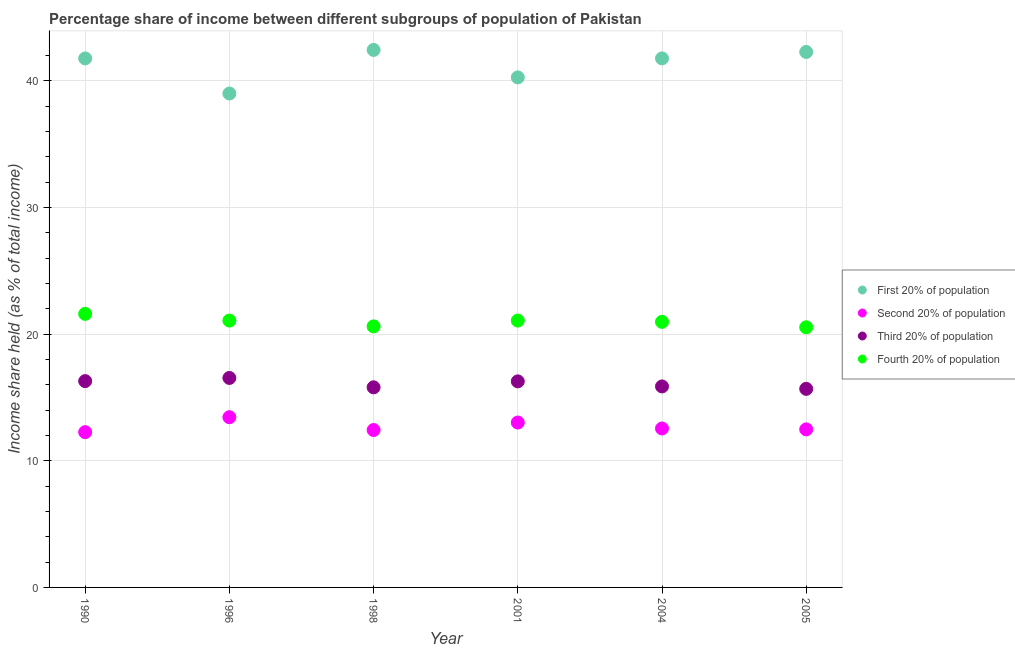How many different coloured dotlines are there?
Make the answer very short. 4. What is the share of the income held by second 20% of the population in 1990?
Your answer should be compact. 12.26. Across all years, what is the maximum share of the income held by first 20% of the population?
Your answer should be very brief. 42.44. Across all years, what is the minimum share of the income held by third 20% of the population?
Provide a succinct answer. 15.68. In which year was the share of the income held by third 20% of the population maximum?
Offer a terse response. 1996. In which year was the share of the income held by fourth 20% of the population minimum?
Keep it short and to the point. 2005. What is the total share of the income held by second 20% of the population in the graph?
Offer a terse response. 76.18. What is the difference between the share of the income held by fourth 20% of the population in 1990 and that in 2004?
Your answer should be very brief. 0.63. What is the difference between the share of the income held by fourth 20% of the population in 1990 and the share of the income held by first 20% of the population in 1998?
Offer a very short reply. -20.84. What is the average share of the income held by second 20% of the population per year?
Your response must be concise. 12.7. In the year 2005, what is the difference between the share of the income held by third 20% of the population and share of the income held by fourth 20% of the population?
Offer a terse response. -4.86. What is the ratio of the share of the income held by second 20% of the population in 1990 to that in 1996?
Your answer should be very brief. 0.91. Is the difference between the share of the income held by first 20% of the population in 1990 and 1996 greater than the difference between the share of the income held by second 20% of the population in 1990 and 1996?
Your response must be concise. Yes. What is the difference between the highest and the second highest share of the income held by first 20% of the population?
Provide a short and direct response. 0.16. What is the difference between the highest and the lowest share of the income held by third 20% of the population?
Provide a succinct answer. 0.86. Is it the case that in every year, the sum of the share of the income held by first 20% of the population and share of the income held by second 20% of the population is greater than the share of the income held by third 20% of the population?
Give a very brief answer. Yes. Does the share of the income held by second 20% of the population monotonically increase over the years?
Offer a very short reply. No. How many years are there in the graph?
Ensure brevity in your answer.  6. What is the difference between two consecutive major ticks on the Y-axis?
Offer a very short reply. 10. Are the values on the major ticks of Y-axis written in scientific E-notation?
Offer a terse response. No. Does the graph contain grids?
Offer a very short reply. Yes. How are the legend labels stacked?
Your response must be concise. Vertical. What is the title of the graph?
Keep it short and to the point. Percentage share of income between different subgroups of population of Pakistan. Does "Argument" appear as one of the legend labels in the graph?
Give a very brief answer. No. What is the label or title of the Y-axis?
Provide a succinct answer. Income share held (as % of total income). What is the Income share held (as % of total income) in First 20% of population in 1990?
Give a very brief answer. 41.77. What is the Income share held (as % of total income) of Second 20% of population in 1990?
Ensure brevity in your answer.  12.26. What is the Income share held (as % of total income) in Third 20% of population in 1990?
Your response must be concise. 16.29. What is the Income share held (as % of total income) in Fourth 20% of population in 1990?
Ensure brevity in your answer.  21.6. What is the Income share held (as % of total income) in Second 20% of population in 1996?
Make the answer very short. 13.44. What is the Income share held (as % of total income) of Third 20% of population in 1996?
Provide a short and direct response. 16.54. What is the Income share held (as % of total income) in Fourth 20% of population in 1996?
Give a very brief answer. 21.07. What is the Income share held (as % of total income) of First 20% of population in 1998?
Offer a terse response. 42.44. What is the Income share held (as % of total income) in Second 20% of population in 1998?
Keep it short and to the point. 12.43. What is the Income share held (as % of total income) in Fourth 20% of population in 1998?
Your answer should be very brief. 20.61. What is the Income share held (as % of total income) in First 20% of population in 2001?
Ensure brevity in your answer.  40.27. What is the Income share held (as % of total income) of Second 20% of population in 2001?
Your answer should be very brief. 13.02. What is the Income share held (as % of total income) in Third 20% of population in 2001?
Provide a short and direct response. 16.27. What is the Income share held (as % of total income) in Fourth 20% of population in 2001?
Your answer should be compact. 21.07. What is the Income share held (as % of total income) of First 20% of population in 2004?
Offer a very short reply. 41.77. What is the Income share held (as % of total income) in Second 20% of population in 2004?
Provide a short and direct response. 12.55. What is the Income share held (as % of total income) of Third 20% of population in 2004?
Give a very brief answer. 15.87. What is the Income share held (as % of total income) in Fourth 20% of population in 2004?
Offer a very short reply. 20.97. What is the Income share held (as % of total income) of First 20% of population in 2005?
Keep it short and to the point. 42.28. What is the Income share held (as % of total income) in Second 20% of population in 2005?
Give a very brief answer. 12.48. What is the Income share held (as % of total income) of Third 20% of population in 2005?
Your answer should be compact. 15.68. What is the Income share held (as % of total income) in Fourth 20% of population in 2005?
Make the answer very short. 20.54. Across all years, what is the maximum Income share held (as % of total income) in First 20% of population?
Provide a succinct answer. 42.44. Across all years, what is the maximum Income share held (as % of total income) in Second 20% of population?
Give a very brief answer. 13.44. Across all years, what is the maximum Income share held (as % of total income) of Third 20% of population?
Your answer should be compact. 16.54. Across all years, what is the maximum Income share held (as % of total income) of Fourth 20% of population?
Offer a very short reply. 21.6. Across all years, what is the minimum Income share held (as % of total income) of First 20% of population?
Offer a very short reply. 39. Across all years, what is the minimum Income share held (as % of total income) in Second 20% of population?
Your answer should be compact. 12.26. Across all years, what is the minimum Income share held (as % of total income) of Third 20% of population?
Your answer should be very brief. 15.68. Across all years, what is the minimum Income share held (as % of total income) in Fourth 20% of population?
Your response must be concise. 20.54. What is the total Income share held (as % of total income) in First 20% of population in the graph?
Make the answer very short. 247.53. What is the total Income share held (as % of total income) in Second 20% of population in the graph?
Your answer should be very brief. 76.18. What is the total Income share held (as % of total income) in Third 20% of population in the graph?
Ensure brevity in your answer.  96.45. What is the total Income share held (as % of total income) in Fourth 20% of population in the graph?
Provide a short and direct response. 125.86. What is the difference between the Income share held (as % of total income) of First 20% of population in 1990 and that in 1996?
Make the answer very short. 2.77. What is the difference between the Income share held (as % of total income) of Second 20% of population in 1990 and that in 1996?
Your answer should be very brief. -1.18. What is the difference between the Income share held (as % of total income) in Third 20% of population in 1990 and that in 1996?
Offer a terse response. -0.25. What is the difference between the Income share held (as % of total income) in Fourth 20% of population in 1990 and that in 1996?
Your response must be concise. 0.53. What is the difference between the Income share held (as % of total income) of First 20% of population in 1990 and that in 1998?
Keep it short and to the point. -0.67. What is the difference between the Income share held (as % of total income) of Second 20% of population in 1990 and that in 1998?
Give a very brief answer. -0.17. What is the difference between the Income share held (as % of total income) in Third 20% of population in 1990 and that in 1998?
Offer a terse response. 0.49. What is the difference between the Income share held (as % of total income) in Second 20% of population in 1990 and that in 2001?
Offer a very short reply. -0.76. What is the difference between the Income share held (as % of total income) in Fourth 20% of population in 1990 and that in 2001?
Your answer should be very brief. 0.53. What is the difference between the Income share held (as % of total income) in Second 20% of population in 1990 and that in 2004?
Offer a very short reply. -0.29. What is the difference between the Income share held (as % of total income) of Third 20% of population in 1990 and that in 2004?
Make the answer very short. 0.42. What is the difference between the Income share held (as % of total income) of Fourth 20% of population in 1990 and that in 2004?
Your answer should be compact. 0.63. What is the difference between the Income share held (as % of total income) in First 20% of population in 1990 and that in 2005?
Your answer should be very brief. -0.51. What is the difference between the Income share held (as % of total income) of Second 20% of population in 1990 and that in 2005?
Offer a very short reply. -0.22. What is the difference between the Income share held (as % of total income) of Third 20% of population in 1990 and that in 2005?
Give a very brief answer. 0.61. What is the difference between the Income share held (as % of total income) of Fourth 20% of population in 1990 and that in 2005?
Make the answer very short. 1.06. What is the difference between the Income share held (as % of total income) in First 20% of population in 1996 and that in 1998?
Give a very brief answer. -3.44. What is the difference between the Income share held (as % of total income) of Second 20% of population in 1996 and that in 1998?
Provide a succinct answer. 1.01. What is the difference between the Income share held (as % of total income) of Third 20% of population in 1996 and that in 1998?
Your answer should be compact. 0.74. What is the difference between the Income share held (as % of total income) in Fourth 20% of population in 1996 and that in 1998?
Keep it short and to the point. 0.46. What is the difference between the Income share held (as % of total income) of First 20% of population in 1996 and that in 2001?
Offer a terse response. -1.27. What is the difference between the Income share held (as % of total income) in Second 20% of population in 1996 and that in 2001?
Keep it short and to the point. 0.42. What is the difference between the Income share held (as % of total income) of Third 20% of population in 1996 and that in 2001?
Your answer should be very brief. 0.27. What is the difference between the Income share held (as % of total income) in First 20% of population in 1996 and that in 2004?
Your answer should be compact. -2.77. What is the difference between the Income share held (as % of total income) of Second 20% of population in 1996 and that in 2004?
Your response must be concise. 0.89. What is the difference between the Income share held (as % of total income) in Third 20% of population in 1996 and that in 2004?
Give a very brief answer. 0.67. What is the difference between the Income share held (as % of total income) in Fourth 20% of population in 1996 and that in 2004?
Offer a very short reply. 0.1. What is the difference between the Income share held (as % of total income) of First 20% of population in 1996 and that in 2005?
Provide a succinct answer. -3.28. What is the difference between the Income share held (as % of total income) in Third 20% of population in 1996 and that in 2005?
Provide a succinct answer. 0.86. What is the difference between the Income share held (as % of total income) in Fourth 20% of population in 1996 and that in 2005?
Offer a very short reply. 0.53. What is the difference between the Income share held (as % of total income) of First 20% of population in 1998 and that in 2001?
Ensure brevity in your answer.  2.17. What is the difference between the Income share held (as % of total income) in Second 20% of population in 1998 and that in 2001?
Provide a succinct answer. -0.59. What is the difference between the Income share held (as % of total income) of Third 20% of population in 1998 and that in 2001?
Give a very brief answer. -0.47. What is the difference between the Income share held (as % of total income) in Fourth 20% of population in 1998 and that in 2001?
Offer a terse response. -0.46. What is the difference between the Income share held (as % of total income) in First 20% of population in 1998 and that in 2004?
Make the answer very short. 0.67. What is the difference between the Income share held (as % of total income) of Second 20% of population in 1998 and that in 2004?
Make the answer very short. -0.12. What is the difference between the Income share held (as % of total income) of Third 20% of population in 1998 and that in 2004?
Offer a very short reply. -0.07. What is the difference between the Income share held (as % of total income) of Fourth 20% of population in 1998 and that in 2004?
Provide a short and direct response. -0.36. What is the difference between the Income share held (as % of total income) in First 20% of population in 1998 and that in 2005?
Give a very brief answer. 0.16. What is the difference between the Income share held (as % of total income) in Second 20% of population in 1998 and that in 2005?
Your response must be concise. -0.05. What is the difference between the Income share held (as % of total income) of Third 20% of population in 1998 and that in 2005?
Your answer should be compact. 0.12. What is the difference between the Income share held (as % of total income) in Fourth 20% of population in 1998 and that in 2005?
Give a very brief answer. 0.07. What is the difference between the Income share held (as % of total income) in First 20% of population in 2001 and that in 2004?
Keep it short and to the point. -1.5. What is the difference between the Income share held (as % of total income) in Second 20% of population in 2001 and that in 2004?
Your response must be concise. 0.47. What is the difference between the Income share held (as % of total income) in Fourth 20% of population in 2001 and that in 2004?
Give a very brief answer. 0.1. What is the difference between the Income share held (as % of total income) of First 20% of population in 2001 and that in 2005?
Give a very brief answer. -2.01. What is the difference between the Income share held (as % of total income) in Second 20% of population in 2001 and that in 2005?
Provide a short and direct response. 0.54. What is the difference between the Income share held (as % of total income) of Third 20% of population in 2001 and that in 2005?
Offer a terse response. 0.59. What is the difference between the Income share held (as % of total income) in Fourth 20% of population in 2001 and that in 2005?
Give a very brief answer. 0.53. What is the difference between the Income share held (as % of total income) in First 20% of population in 2004 and that in 2005?
Offer a terse response. -0.51. What is the difference between the Income share held (as % of total income) of Second 20% of population in 2004 and that in 2005?
Give a very brief answer. 0.07. What is the difference between the Income share held (as % of total income) in Third 20% of population in 2004 and that in 2005?
Your answer should be very brief. 0.19. What is the difference between the Income share held (as % of total income) of Fourth 20% of population in 2004 and that in 2005?
Your response must be concise. 0.43. What is the difference between the Income share held (as % of total income) of First 20% of population in 1990 and the Income share held (as % of total income) of Second 20% of population in 1996?
Give a very brief answer. 28.33. What is the difference between the Income share held (as % of total income) of First 20% of population in 1990 and the Income share held (as % of total income) of Third 20% of population in 1996?
Your response must be concise. 25.23. What is the difference between the Income share held (as % of total income) of First 20% of population in 1990 and the Income share held (as % of total income) of Fourth 20% of population in 1996?
Your answer should be compact. 20.7. What is the difference between the Income share held (as % of total income) in Second 20% of population in 1990 and the Income share held (as % of total income) in Third 20% of population in 1996?
Give a very brief answer. -4.28. What is the difference between the Income share held (as % of total income) of Second 20% of population in 1990 and the Income share held (as % of total income) of Fourth 20% of population in 1996?
Keep it short and to the point. -8.81. What is the difference between the Income share held (as % of total income) in Third 20% of population in 1990 and the Income share held (as % of total income) in Fourth 20% of population in 1996?
Provide a succinct answer. -4.78. What is the difference between the Income share held (as % of total income) of First 20% of population in 1990 and the Income share held (as % of total income) of Second 20% of population in 1998?
Keep it short and to the point. 29.34. What is the difference between the Income share held (as % of total income) in First 20% of population in 1990 and the Income share held (as % of total income) in Third 20% of population in 1998?
Provide a succinct answer. 25.97. What is the difference between the Income share held (as % of total income) of First 20% of population in 1990 and the Income share held (as % of total income) of Fourth 20% of population in 1998?
Make the answer very short. 21.16. What is the difference between the Income share held (as % of total income) in Second 20% of population in 1990 and the Income share held (as % of total income) in Third 20% of population in 1998?
Give a very brief answer. -3.54. What is the difference between the Income share held (as % of total income) in Second 20% of population in 1990 and the Income share held (as % of total income) in Fourth 20% of population in 1998?
Your answer should be very brief. -8.35. What is the difference between the Income share held (as % of total income) in Third 20% of population in 1990 and the Income share held (as % of total income) in Fourth 20% of population in 1998?
Keep it short and to the point. -4.32. What is the difference between the Income share held (as % of total income) of First 20% of population in 1990 and the Income share held (as % of total income) of Second 20% of population in 2001?
Make the answer very short. 28.75. What is the difference between the Income share held (as % of total income) of First 20% of population in 1990 and the Income share held (as % of total income) of Fourth 20% of population in 2001?
Make the answer very short. 20.7. What is the difference between the Income share held (as % of total income) in Second 20% of population in 1990 and the Income share held (as % of total income) in Third 20% of population in 2001?
Make the answer very short. -4.01. What is the difference between the Income share held (as % of total income) in Second 20% of population in 1990 and the Income share held (as % of total income) in Fourth 20% of population in 2001?
Ensure brevity in your answer.  -8.81. What is the difference between the Income share held (as % of total income) of Third 20% of population in 1990 and the Income share held (as % of total income) of Fourth 20% of population in 2001?
Make the answer very short. -4.78. What is the difference between the Income share held (as % of total income) in First 20% of population in 1990 and the Income share held (as % of total income) in Second 20% of population in 2004?
Provide a short and direct response. 29.22. What is the difference between the Income share held (as % of total income) of First 20% of population in 1990 and the Income share held (as % of total income) of Third 20% of population in 2004?
Your response must be concise. 25.9. What is the difference between the Income share held (as % of total income) in First 20% of population in 1990 and the Income share held (as % of total income) in Fourth 20% of population in 2004?
Provide a succinct answer. 20.8. What is the difference between the Income share held (as % of total income) in Second 20% of population in 1990 and the Income share held (as % of total income) in Third 20% of population in 2004?
Offer a terse response. -3.61. What is the difference between the Income share held (as % of total income) of Second 20% of population in 1990 and the Income share held (as % of total income) of Fourth 20% of population in 2004?
Make the answer very short. -8.71. What is the difference between the Income share held (as % of total income) in Third 20% of population in 1990 and the Income share held (as % of total income) in Fourth 20% of population in 2004?
Keep it short and to the point. -4.68. What is the difference between the Income share held (as % of total income) in First 20% of population in 1990 and the Income share held (as % of total income) in Second 20% of population in 2005?
Provide a succinct answer. 29.29. What is the difference between the Income share held (as % of total income) in First 20% of population in 1990 and the Income share held (as % of total income) in Third 20% of population in 2005?
Offer a terse response. 26.09. What is the difference between the Income share held (as % of total income) of First 20% of population in 1990 and the Income share held (as % of total income) of Fourth 20% of population in 2005?
Provide a succinct answer. 21.23. What is the difference between the Income share held (as % of total income) in Second 20% of population in 1990 and the Income share held (as % of total income) in Third 20% of population in 2005?
Keep it short and to the point. -3.42. What is the difference between the Income share held (as % of total income) in Second 20% of population in 1990 and the Income share held (as % of total income) in Fourth 20% of population in 2005?
Ensure brevity in your answer.  -8.28. What is the difference between the Income share held (as % of total income) in Third 20% of population in 1990 and the Income share held (as % of total income) in Fourth 20% of population in 2005?
Make the answer very short. -4.25. What is the difference between the Income share held (as % of total income) of First 20% of population in 1996 and the Income share held (as % of total income) of Second 20% of population in 1998?
Give a very brief answer. 26.57. What is the difference between the Income share held (as % of total income) in First 20% of population in 1996 and the Income share held (as % of total income) in Third 20% of population in 1998?
Ensure brevity in your answer.  23.2. What is the difference between the Income share held (as % of total income) of First 20% of population in 1996 and the Income share held (as % of total income) of Fourth 20% of population in 1998?
Make the answer very short. 18.39. What is the difference between the Income share held (as % of total income) in Second 20% of population in 1996 and the Income share held (as % of total income) in Third 20% of population in 1998?
Provide a short and direct response. -2.36. What is the difference between the Income share held (as % of total income) in Second 20% of population in 1996 and the Income share held (as % of total income) in Fourth 20% of population in 1998?
Offer a very short reply. -7.17. What is the difference between the Income share held (as % of total income) of Third 20% of population in 1996 and the Income share held (as % of total income) of Fourth 20% of population in 1998?
Your answer should be very brief. -4.07. What is the difference between the Income share held (as % of total income) in First 20% of population in 1996 and the Income share held (as % of total income) in Second 20% of population in 2001?
Make the answer very short. 25.98. What is the difference between the Income share held (as % of total income) in First 20% of population in 1996 and the Income share held (as % of total income) in Third 20% of population in 2001?
Give a very brief answer. 22.73. What is the difference between the Income share held (as % of total income) in First 20% of population in 1996 and the Income share held (as % of total income) in Fourth 20% of population in 2001?
Ensure brevity in your answer.  17.93. What is the difference between the Income share held (as % of total income) in Second 20% of population in 1996 and the Income share held (as % of total income) in Third 20% of population in 2001?
Offer a very short reply. -2.83. What is the difference between the Income share held (as % of total income) of Second 20% of population in 1996 and the Income share held (as % of total income) of Fourth 20% of population in 2001?
Your answer should be very brief. -7.63. What is the difference between the Income share held (as % of total income) of Third 20% of population in 1996 and the Income share held (as % of total income) of Fourth 20% of population in 2001?
Offer a terse response. -4.53. What is the difference between the Income share held (as % of total income) in First 20% of population in 1996 and the Income share held (as % of total income) in Second 20% of population in 2004?
Ensure brevity in your answer.  26.45. What is the difference between the Income share held (as % of total income) in First 20% of population in 1996 and the Income share held (as % of total income) in Third 20% of population in 2004?
Provide a succinct answer. 23.13. What is the difference between the Income share held (as % of total income) of First 20% of population in 1996 and the Income share held (as % of total income) of Fourth 20% of population in 2004?
Provide a succinct answer. 18.03. What is the difference between the Income share held (as % of total income) of Second 20% of population in 1996 and the Income share held (as % of total income) of Third 20% of population in 2004?
Offer a very short reply. -2.43. What is the difference between the Income share held (as % of total income) in Second 20% of population in 1996 and the Income share held (as % of total income) in Fourth 20% of population in 2004?
Offer a very short reply. -7.53. What is the difference between the Income share held (as % of total income) in Third 20% of population in 1996 and the Income share held (as % of total income) in Fourth 20% of population in 2004?
Provide a short and direct response. -4.43. What is the difference between the Income share held (as % of total income) in First 20% of population in 1996 and the Income share held (as % of total income) in Second 20% of population in 2005?
Offer a very short reply. 26.52. What is the difference between the Income share held (as % of total income) in First 20% of population in 1996 and the Income share held (as % of total income) in Third 20% of population in 2005?
Offer a very short reply. 23.32. What is the difference between the Income share held (as % of total income) of First 20% of population in 1996 and the Income share held (as % of total income) of Fourth 20% of population in 2005?
Make the answer very short. 18.46. What is the difference between the Income share held (as % of total income) in Second 20% of population in 1996 and the Income share held (as % of total income) in Third 20% of population in 2005?
Your answer should be compact. -2.24. What is the difference between the Income share held (as % of total income) of Third 20% of population in 1996 and the Income share held (as % of total income) of Fourth 20% of population in 2005?
Your response must be concise. -4. What is the difference between the Income share held (as % of total income) of First 20% of population in 1998 and the Income share held (as % of total income) of Second 20% of population in 2001?
Offer a terse response. 29.42. What is the difference between the Income share held (as % of total income) of First 20% of population in 1998 and the Income share held (as % of total income) of Third 20% of population in 2001?
Keep it short and to the point. 26.17. What is the difference between the Income share held (as % of total income) of First 20% of population in 1998 and the Income share held (as % of total income) of Fourth 20% of population in 2001?
Offer a terse response. 21.37. What is the difference between the Income share held (as % of total income) of Second 20% of population in 1998 and the Income share held (as % of total income) of Third 20% of population in 2001?
Your answer should be compact. -3.84. What is the difference between the Income share held (as % of total income) in Second 20% of population in 1998 and the Income share held (as % of total income) in Fourth 20% of population in 2001?
Keep it short and to the point. -8.64. What is the difference between the Income share held (as % of total income) of Third 20% of population in 1998 and the Income share held (as % of total income) of Fourth 20% of population in 2001?
Your response must be concise. -5.27. What is the difference between the Income share held (as % of total income) in First 20% of population in 1998 and the Income share held (as % of total income) in Second 20% of population in 2004?
Provide a short and direct response. 29.89. What is the difference between the Income share held (as % of total income) in First 20% of population in 1998 and the Income share held (as % of total income) in Third 20% of population in 2004?
Give a very brief answer. 26.57. What is the difference between the Income share held (as % of total income) of First 20% of population in 1998 and the Income share held (as % of total income) of Fourth 20% of population in 2004?
Keep it short and to the point. 21.47. What is the difference between the Income share held (as % of total income) of Second 20% of population in 1998 and the Income share held (as % of total income) of Third 20% of population in 2004?
Provide a short and direct response. -3.44. What is the difference between the Income share held (as % of total income) of Second 20% of population in 1998 and the Income share held (as % of total income) of Fourth 20% of population in 2004?
Your answer should be very brief. -8.54. What is the difference between the Income share held (as % of total income) in Third 20% of population in 1998 and the Income share held (as % of total income) in Fourth 20% of population in 2004?
Your response must be concise. -5.17. What is the difference between the Income share held (as % of total income) in First 20% of population in 1998 and the Income share held (as % of total income) in Second 20% of population in 2005?
Give a very brief answer. 29.96. What is the difference between the Income share held (as % of total income) in First 20% of population in 1998 and the Income share held (as % of total income) in Third 20% of population in 2005?
Keep it short and to the point. 26.76. What is the difference between the Income share held (as % of total income) in First 20% of population in 1998 and the Income share held (as % of total income) in Fourth 20% of population in 2005?
Provide a succinct answer. 21.9. What is the difference between the Income share held (as % of total income) in Second 20% of population in 1998 and the Income share held (as % of total income) in Third 20% of population in 2005?
Your answer should be very brief. -3.25. What is the difference between the Income share held (as % of total income) in Second 20% of population in 1998 and the Income share held (as % of total income) in Fourth 20% of population in 2005?
Your answer should be compact. -8.11. What is the difference between the Income share held (as % of total income) of Third 20% of population in 1998 and the Income share held (as % of total income) of Fourth 20% of population in 2005?
Your answer should be compact. -4.74. What is the difference between the Income share held (as % of total income) of First 20% of population in 2001 and the Income share held (as % of total income) of Second 20% of population in 2004?
Your response must be concise. 27.72. What is the difference between the Income share held (as % of total income) of First 20% of population in 2001 and the Income share held (as % of total income) of Third 20% of population in 2004?
Your response must be concise. 24.4. What is the difference between the Income share held (as % of total income) in First 20% of population in 2001 and the Income share held (as % of total income) in Fourth 20% of population in 2004?
Your answer should be compact. 19.3. What is the difference between the Income share held (as % of total income) of Second 20% of population in 2001 and the Income share held (as % of total income) of Third 20% of population in 2004?
Your answer should be very brief. -2.85. What is the difference between the Income share held (as % of total income) in Second 20% of population in 2001 and the Income share held (as % of total income) in Fourth 20% of population in 2004?
Your answer should be compact. -7.95. What is the difference between the Income share held (as % of total income) of Third 20% of population in 2001 and the Income share held (as % of total income) of Fourth 20% of population in 2004?
Provide a succinct answer. -4.7. What is the difference between the Income share held (as % of total income) in First 20% of population in 2001 and the Income share held (as % of total income) in Second 20% of population in 2005?
Make the answer very short. 27.79. What is the difference between the Income share held (as % of total income) of First 20% of population in 2001 and the Income share held (as % of total income) of Third 20% of population in 2005?
Offer a very short reply. 24.59. What is the difference between the Income share held (as % of total income) in First 20% of population in 2001 and the Income share held (as % of total income) in Fourth 20% of population in 2005?
Your answer should be compact. 19.73. What is the difference between the Income share held (as % of total income) of Second 20% of population in 2001 and the Income share held (as % of total income) of Third 20% of population in 2005?
Your answer should be compact. -2.66. What is the difference between the Income share held (as % of total income) of Second 20% of population in 2001 and the Income share held (as % of total income) of Fourth 20% of population in 2005?
Offer a terse response. -7.52. What is the difference between the Income share held (as % of total income) in Third 20% of population in 2001 and the Income share held (as % of total income) in Fourth 20% of population in 2005?
Your response must be concise. -4.27. What is the difference between the Income share held (as % of total income) in First 20% of population in 2004 and the Income share held (as % of total income) in Second 20% of population in 2005?
Provide a short and direct response. 29.29. What is the difference between the Income share held (as % of total income) in First 20% of population in 2004 and the Income share held (as % of total income) in Third 20% of population in 2005?
Make the answer very short. 26.09. What is the difference between the Income share held (as % of total income) of First 20% of population in 2004 and the Income share held (as % of total income) of Fourth 20% of population in 2005?
Ensure brevity in your answer.  21.23. What is the difference between the Income share held (as % of total income) in Second 20% of population in 2004 and the Income share held (as % of total income) in Third 20% of population in 2005?
Provide a succinct answer. -3.13. What is the difference between the Income share held (as % of total income) in Second 20% of population in 2004 and the Income share held (as % of total income) in Fourth 20% of population in 2005?
Your response must be concise. -7.99. What is the difference between the Income share held (as % of total income) of Third 20% of population in 2004 and the Income share held (as % of total income) of Fourth 20% of population in 2005?
Your response must be concise. -4.67. What is the average Income share held (as % of total income) of First 20% of population per year?
Provide a succinct answer. 41.26. What is the average Income share held (as % of total income) of Second 20% of population per year?
Your answer should be compact. 12.7. What is the average Income share held (as % of total income) in Third 20% of population per year?
Your response must be concise. 16.07. What is the average Income share held (as % of total income) of Fourth 20% of population per year?
Keep it short and to the point. 20.98. In the year 1990, what is the difference between the Income share held (as % of total income) in First 20% of population and Income share held (as % of total income) in Second 20% of population?
Your answer should be compact. 29.51. In the year 1990, what is the difference between the Income share held (as % of total income) of First 20% of population and Income share held (as % of total income) of Third 20% of population?
Your answer should be compact. 25.48. In the year 1990, what is the difference between the Income share held (as % of total income) in First 20% of population and Income share held (as % of total income) in Fourth 20% of population?
Offer a terse response. 20.17. In the year 1990, what is the difference between the Income share held (as % of total income) of Second 20% of population and Income share held (as % of total income) of Third 20% of population?
Keep it short and to the point. -4.03. In the year 1990, what is the difference between the Income share held (as % of total income) of Second 20% of population and Income share held (as % of total income) of Fourth 20% of population?
Provide a short and direct response. -9.34. In the year 1990, what is the difference between the Income share held (as % of total income) in Third 20% of population and Income share held (as % of total income) in Fourth 20% of population?
Make the answer very short. -5.31. In the year 1996, what is the difference between the Income share held (as % of total income) of First 20% of population and Income share held (as % of total income) of Second 20% of population?
Your response must be concise. 25.56. In the year 1996, what is the difference between the Income share held (as % of total income) of First 20% of population and Income share held (as % of total income) of Third 20% of population?
Offer a terse response. 22.46. In the year 1996, what is the difference between the Income share held (as % of total income) in First 20% of population and Income share held (as % of total income) in Fourth 20% of population?
Make the answer very short. 17.93. In the year 1996, what is the difference between the Income share held (as % of total income) of Second 20% of population and Income share held (as % of total income) of Third 20% of population?
Your response must be concise. -3.1. In the year 1996, what is the difference between the Income share held (as % of total income) of Second 20% of population and Income share held (as % of total income) of Fourth 20% of population?
Offer a very short reply. -7.63. In the year 1996, what is the difference between the Income share held (as % of total income) of Third 20% of population and Income share held (as % of total income) of Fourth 20% of population?
Keep it short and to the point. -4.53. In the year 1998, what is the difference between the Income share held (as % of total income) in First 20% of population and Income share held (as % of total income) in Second 20% of population?
Offer a terse response. 30.01. In the year 1998, what is the difference between the Income share held (as % of total income) in First 20% of population and Income share held (as % of total income) in Third 20% of population?
Provide a succinct answer. 26.64. In the year 1998, what is the difference between the Income share held (as % of total income) in First 20% of population and Income share held (as % of total income) in Fourth 20% of population?
Your answer should be compact. 21.83. In the year 1998, what is the difference between the Income share held (as % of total income) in Second 20% of population and Income share held (as % of total income) in Third 20% of population?
Keep it short and to the point. -3.37. In the year 1998, what is the difference between the Income share held (as % of total income) of Second 20% of population and Income share held (as % of total income) of Fourth 20% of population?
Offer a very short reply. -8.18. In the year 1998, what is the difference between the Income share held (as % of total income) of Third 20% of population and Income share held (as % of total income) of Fourth 20% of population?
Your answer should be compact. -4.81. In the year 2001, what is the difference between the Income share held (as % of total income) of First 20% of population and Income share held (as % of total income) of Second 20% of population?
Your response must be concise. 27.25. In the year 2001, what is the difference between the Income share held (as % of total income) in First 20% of population and Income share held (as % of total income) in Third 20% of population?
Offer a very short reply. 24. In the year 2001, what is the difference between the Income share held (as % of total income) in First 20% of population and Income share held (as % of total income) in Fourth 20% of population?
Provide a short and direct response. 19.2. In the year 2001, what is the difference between the Income share held (as % of total income) of Second 20% of population and Income share held (as % of total income) of Third 20% of population?
Your response must be concise. -3.25. In the year 2001, what is the difference between the Income share held (as % of total income) in Second 20% of population and Income share held (as % of total income) in Fourth 20% of population?
Provide a succinct answer. -8.05. In the year 2001, what is the difference between the Income share held (as % of total income) of Third 20% of population and Income share held (as % of total income) of Fourth 20% of population?
Ensure brevity in your answer.  -4.8. In the year 2004, what is the difference between the Income share held (as % of total income) in First 20% of population and Income share held (as % of total income) in Second 20% of population?
Offer a terse response. 29.22. In the year 2004, what is the difference between the Income share held (as % of total income) in First 20% of population and Income share held (as % of total income) in Third 20% of population?
Offer a terse response. 25.9. In the year 2004, what is the difference between the Income share held (as % of total income) of First 20% of population and Income share held (as % of total income) of Fourth 20% of population?
Provide a short and direct response. 20.8. In the year 2004, what is the difference between the Income share held (as % of total income) of Second 20% of population and Income share held (as % of total income) of Third 20% of population?
Provide a succinct answer. -3.32. In the year 2004, what is the difference between the Income share held (as % of total income) in Second 20% of population and Income share held (as % of total income) in Fourth 20% of population?
Provide a short and direct response. -8.42. In the year 2005, what is the difference between the Income share held (as % of total income) of First 20% of population and Income share held (as % of total income) of Second 20% of population?
Make the answer very short. 29.8. In the year 2005, what is the difference between the Income share held (as % of total income) in First 20% of population and Income share held (as % of total income) in Third 20% of population?
Your answer should be very brief. 26.6. In the year 2005, what is the difference between the Income share held (as % of total income) of First 20% of population and Income share held (as % of total income) of Fourth 20% of population?
Give a very brief answer. 21.74. In the year 2005, what is the difference between the Income share held (as % of total income) of Second 20% of population and Income share held (as % of total income) of Fourth 20% of population?
Keep it short and to the point. -8.06. In the year 2005, what is the difference between the Income share held (as % of total income) in Third 20% of population and Income share held (as % of total income) in Fourth 20% of population?
Give a very brief answer. -4.86. What is the ratio of the Income share held (as % of total income) of First 20% of population in 1990 to that in 1996?
Your response must be concise. 1.07. What is the ratio of the Income share held (as % of total income) in Second 20% of population in 1990 to that in 1996?
Make the answer very short. 0.91. What is the ratio of the Income share held (as % of total income) in Third 20% of population in 1990 to that in 1996?
Offer a very short reply. 0.98. What is the ratio of the Income share held (as % of total income) in Fourth 20% of population in 1990 to that in 1996?
Offer a terse response. 1.03. What is the ratio of the Income share held (as % of total income) of First 20% of population in 1990 to that in 1998?
Your response must be concise. 0.98. What is the ratio of the Income share held (as % of total income) in Second 20% of population in 1990 to that in 1998?
Your answer should be compact. 0.99. What is the ratio of the Income share held (as % of total income) of Third 20% of population in 1990 to that in 1998?
Your answer should be very brief. 1.03. What is the ratio of the Income share held (as % of total income) of Fourth 20% of population in 1990 to that in 1998?
Make the answer very short. 1.05. What is the ratio of the Income share held (as % of total income) of First 20% of population in 1990 to that in 2001?
Make the answer very short. 1.04. What is the ratio of the Income share held (as % of total income) of Second 20% of population in 1990 to that in 2001?
Ensure brevity in your answer.  0.94. What is the ratio of the Income share held (as % of total income) of Fourth 20% of population in 1990 to that in 2001?
Give a very brief answer. 1.03. What is the ratio of the Income share held (as % of total income) in First 20% of population in 1990 to that in 2004?
Your answer should be very brief. 1. What is the ratio of the Income share held (as % of total income) in Second 20% of population in 1990 to that in 2004?
Offer a terse response. 0.98. What is the ratio of the Income share held (as % of total income) of Third 20% of population in 1990 to that in 2004?
Keep it short and to the point. 1.03. What is the ratio of the Income share held (as % of total income) in First 20% of population in 1990 to that in 2005?
Provide a short and direct response. 0.99. What is the ratio of the Income share held (as % of total income) in Second 20% of population in 1990 to that in 2005?
Offer a very short reply. 0.98. What is the ratio of the Income share held (as % of total income) in Third 20% of population in 1990 to that in 2005?
Ensure brevity in your answer.  1.04. What is the ratio of the Income share held (as % of total income) in Fourth 20% of population in 1990 to that in 2005?
Keep it short and to the point. 1.05. What is the ratio of the Income share held (as % of total income) in First 20% of population in 1996 to that in 1998?
Provide a succinct answer. 0.92. What is the ratio of the Income share held (as % of total income) of Second 20% of population in 1996 to that in 1998?
Offer a terse response. 1.08. What is the ratio of the Income share held (as % of total income) in Third 20% of population in 1996 to that in 1998?
Give a very brief answer. 1.05. What is the ratio of the Income share held (as % of total income) of Fourth 20% of population in 1996 to that in 1998?
Ensure brevity in your answer.  1.02. What is the ratio of the Income share held (as % of total income) in First 20% of population in 1996 to that in 2001?
Offer a terse response. 0.97. What is the ratio of the Income share held (as % of total income) of Second 20% of population in 1996 to that in 2001?
Your answer should be very brief. 1.03. What is the ratio of the Income share held (as % of total income) of Third 20% of population in 1996 to that in 2001?
Ensure brevity in your answer.  1.02. What is the ratio of the Income share held (as % of total income) in First 20% of population in 1996 to that in 2004?
Provide a short and direct response. 0.93. What is the ratio of the Income share held (as % of total income) of Second 20% of population in 1996 to that in 2004?
Ensure brevity in your answer.  1.07. What is the ratio of the Income share held (as % of total income) of Third 20% of population in 1996 to that in 2004?
Offer a very short reply. 1.04. What is the ratio of the Income share held (as % of total income) in First 20% of population in 1996 to that in 2005?
Your response must be concise. 0.92. What is the ratio of the Income share held (as % of total income) in Third 20% of population in 1996 to that in 2005?
Make the answer very short. 1.05. What is the ratio of the Income share held (as % of total income) in Fourth 20% of population in 1996 to that in 2005?
Offer a terse response. 1.03. What is the ratio of the Income share held (as % of total income) in First 20% of population in 1998 to that in 2001?
Your answer should be compact. 1.05. What is the ratio of the Income share held (as % of total income) in Second 20% of population in 1998 to that in 2001?
Ensure brevity in your answer.  0.95. What is the ratio of the Income share held (as % of total income) in Third 20% of population in 1998 to that in 2001?
Your response must be concise. 0.97. What is the ratio of the Income share held (as % of total income) in Fourth 20% of population in 1998 to that in 2001?
Your response must be concise. 0.98. What is the ratio of the Income share held (as % of total income) in Fourth 20% of population in 1998 to that in 2004?
Offer a very short reply. 0.98. What is the ratio of the Income share held (as % of total income) of Second 20% of population in 1998 to that in 2005?
Give a very brief answer. 1. What is the ratio of the Income share held (as % of total income) in Third 20% of population in 1998 to that in 2005?
Make the answer very short. 1.01. What is the ratio of the Income share held (as % of total income) in First 20% of population in 2001 to that in 2004?
Your response must be concise. 0.96. What is the ratio of the Income share held (as % of total income) of Second 20% of population in 2001 to that in 2004?
Make the answer very short. 1.04. What is the ratio of the Income share held (as % of total income) in Third 20% of population in 2001 to that in 2004?
Ensure brevity in your answer.  1.03. What is the ratio of the Income share held (as % of total income) in First 20% of population in 2001 to that in 2005?
Ensure brevity in your answer.  0.95. What is the ratio of the Income share held (as % of total income) of Second 20% of population in 2001 to that in 2005?
Offer a very short reply. 1.04. What is the ratio of the Income share held (as % of total income) in Third 20% of population in 2001 to that in 2005?
Offer a terse response. 1.04. What is the ratio of the Income share held (as % of total income) in Fourth 20% of population in 2001 to that in 2005?
Offer a terse response. 1.03. What is the ratio of the Income share held (as % of total income) in First 20% of population in 2004 to that in 2005?
Provide a succinct answer. 0.99. What is the ratio of the Income share held (as % of total income) in Second 20% of population in 2004 to that in 2005?
Offer a very short reply. 1.01. What is the ratio of the Income share held (as % of total income) of Third 20% of population in 2004 to that in 2005?
Ensure brevity in your answer.  1.01. What is the ratio of the Income share held (as % of total income) of Fourth 20% of population in 2004 to that in 2005?
Give a very brief answer. 1.02. What is the difference between the highest and the second highest Income share held (as % of total income) in First 20% of population?
Give a very brief answer. 0.16. What is the difference between the highest and the second highest Income share held (as % of total income) of Second 20% of population?
Make the answer very short. 0.42. What is the difference between the highest and the second highest Income share held (as % of total income) of Third 20% of population?
Give a very brief answer. 0.25. What is the difference between the highest and the second highest Income share held (as % of total income) in Fourth 20% of population?
Your answer should be compact. 0.53. What is the difference between the highest and the lowest Income share held (as % of total income) of First 20% of population?
Ensure brevity in your answer.  3.44. What is the difference between the highest and the lowest Income share held (as % of total income) of Second 20% of population?
Give a very brief answer. 1.18. What is the difference between the highest and the lowest Income share held (as % of total income) in Third 20% of population?
Your answer should be compact. 0.86. What is the difference between the highest and the lowest Income share held (as % of total income) of Fourth 20% of population?
Offer a very short reply. 1.06. 